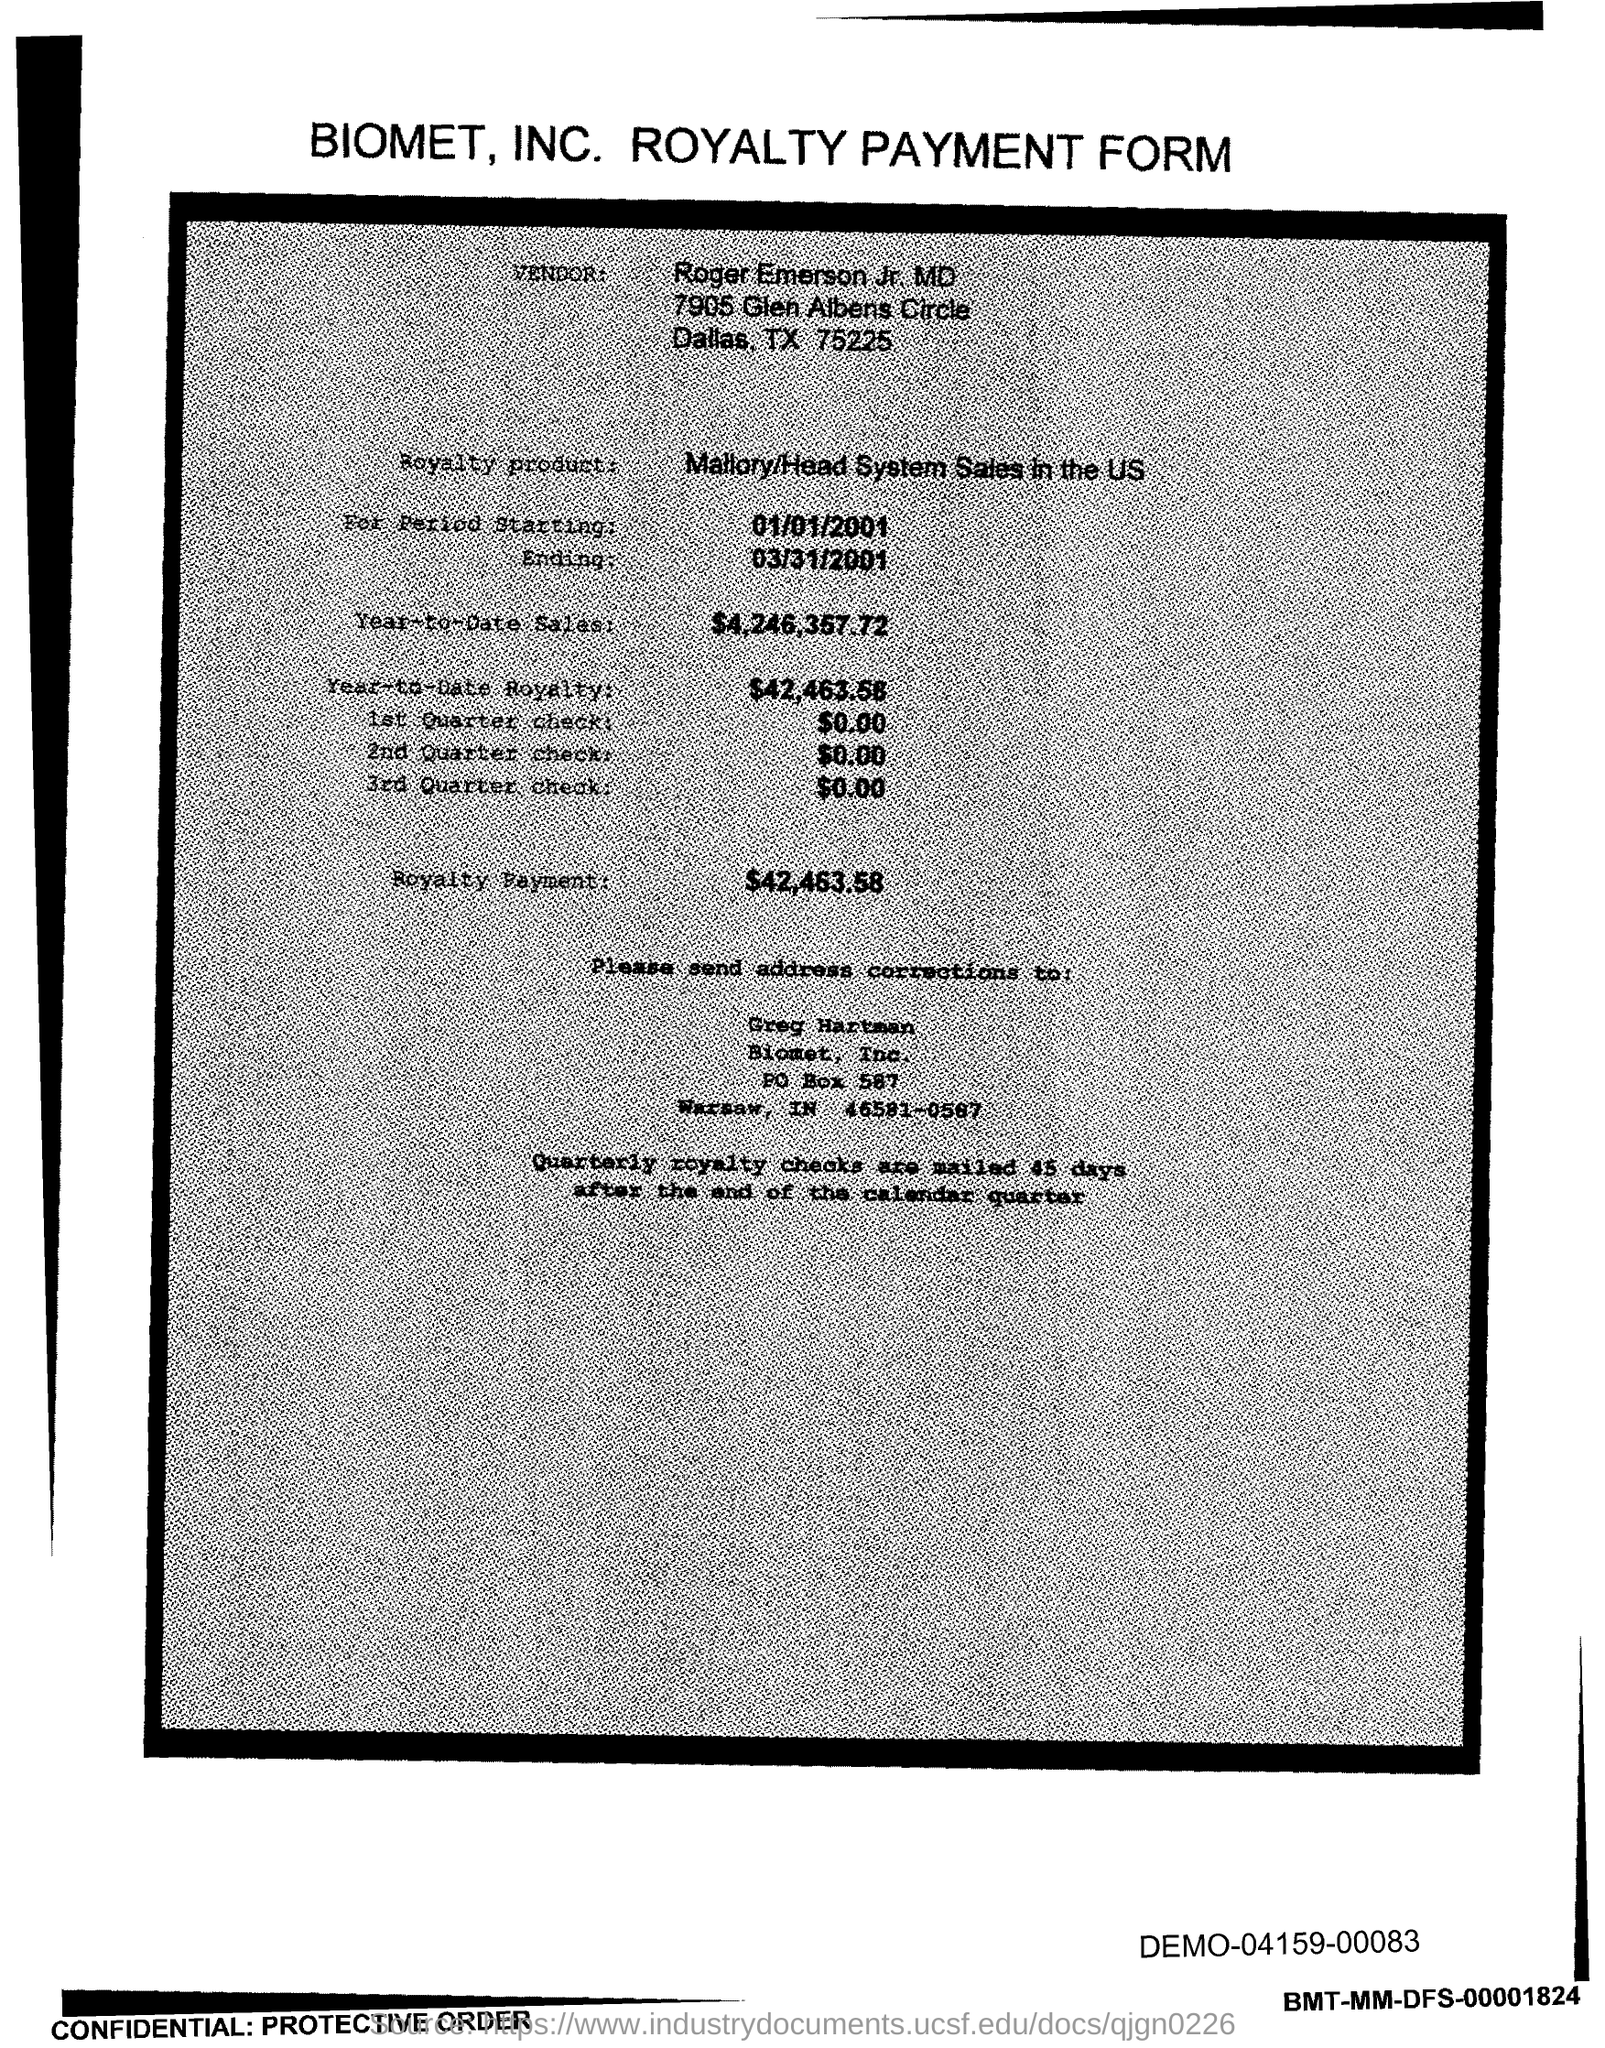What is the po box no. of biomet, inc.?
Offer a terse response. 587. What is the year-to-date sales?
Your answer should be compact. $4,246,357.72. What is  the year-to-date royalty ?
Your answer should be very brief. $42,463.58. What is the royalty payment ?
Provide a short and direct response. $42,463.58. In which state is biomet, inc. located ?
Provide a short and direct response. IN. 